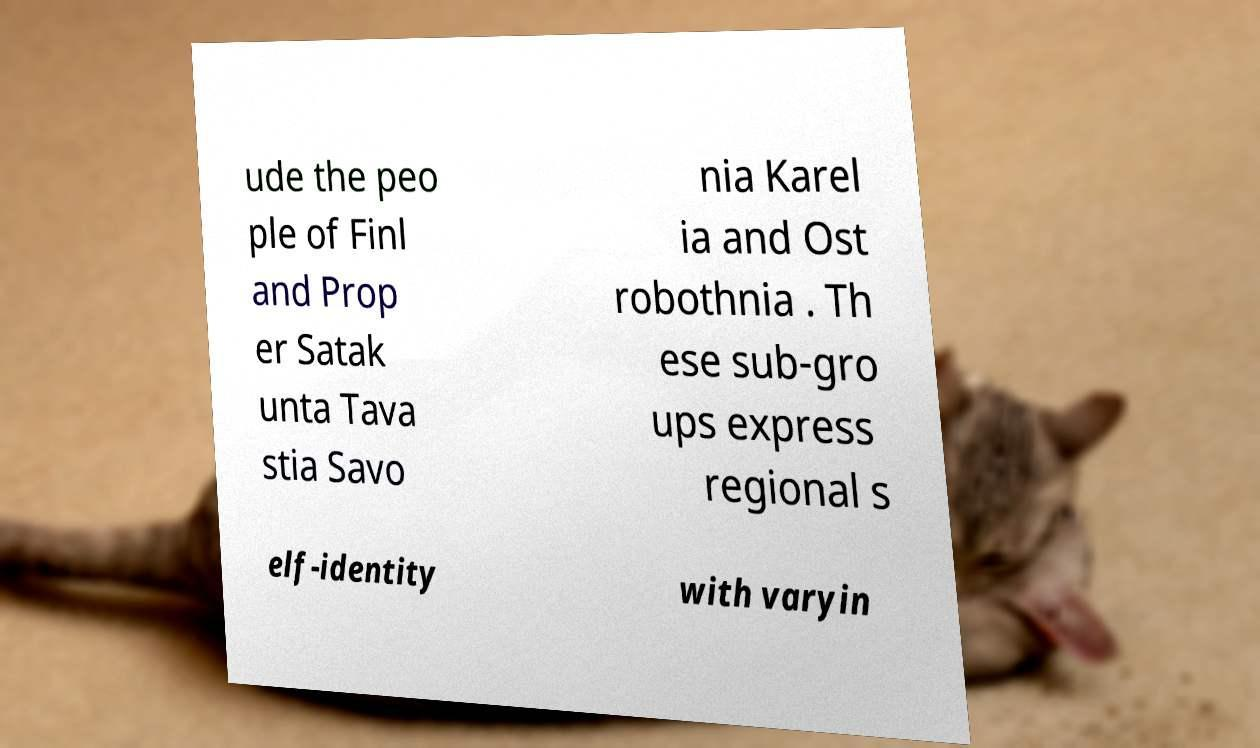Could you assist in decoding the text presented in this image and type it out clearly? ude the peo ple of Finl and Prop er Satak unta Tava stia Savo nia Karel ia and Ost robothnia . Th ese sub-gro ups express regional s elf-identity with varyin 